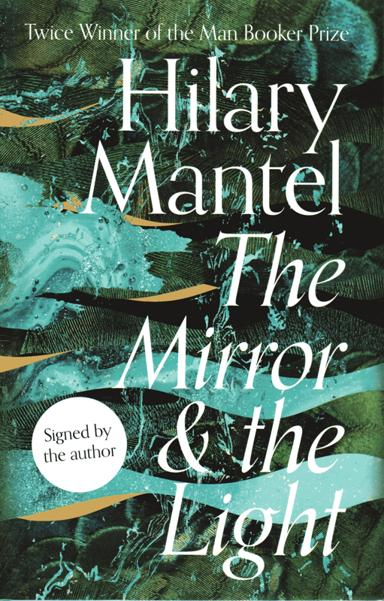What is the name of the book mentioned in the image, and who is the author? The book featured in the image is 'The Mirror and the Light' by Hilary Mantel, an acclaimed British writer known for her rich historical novels. Mantel has earned the prestigious Man Booker Prize twice, confirming her outstanding contribution to contemporary English literature. 